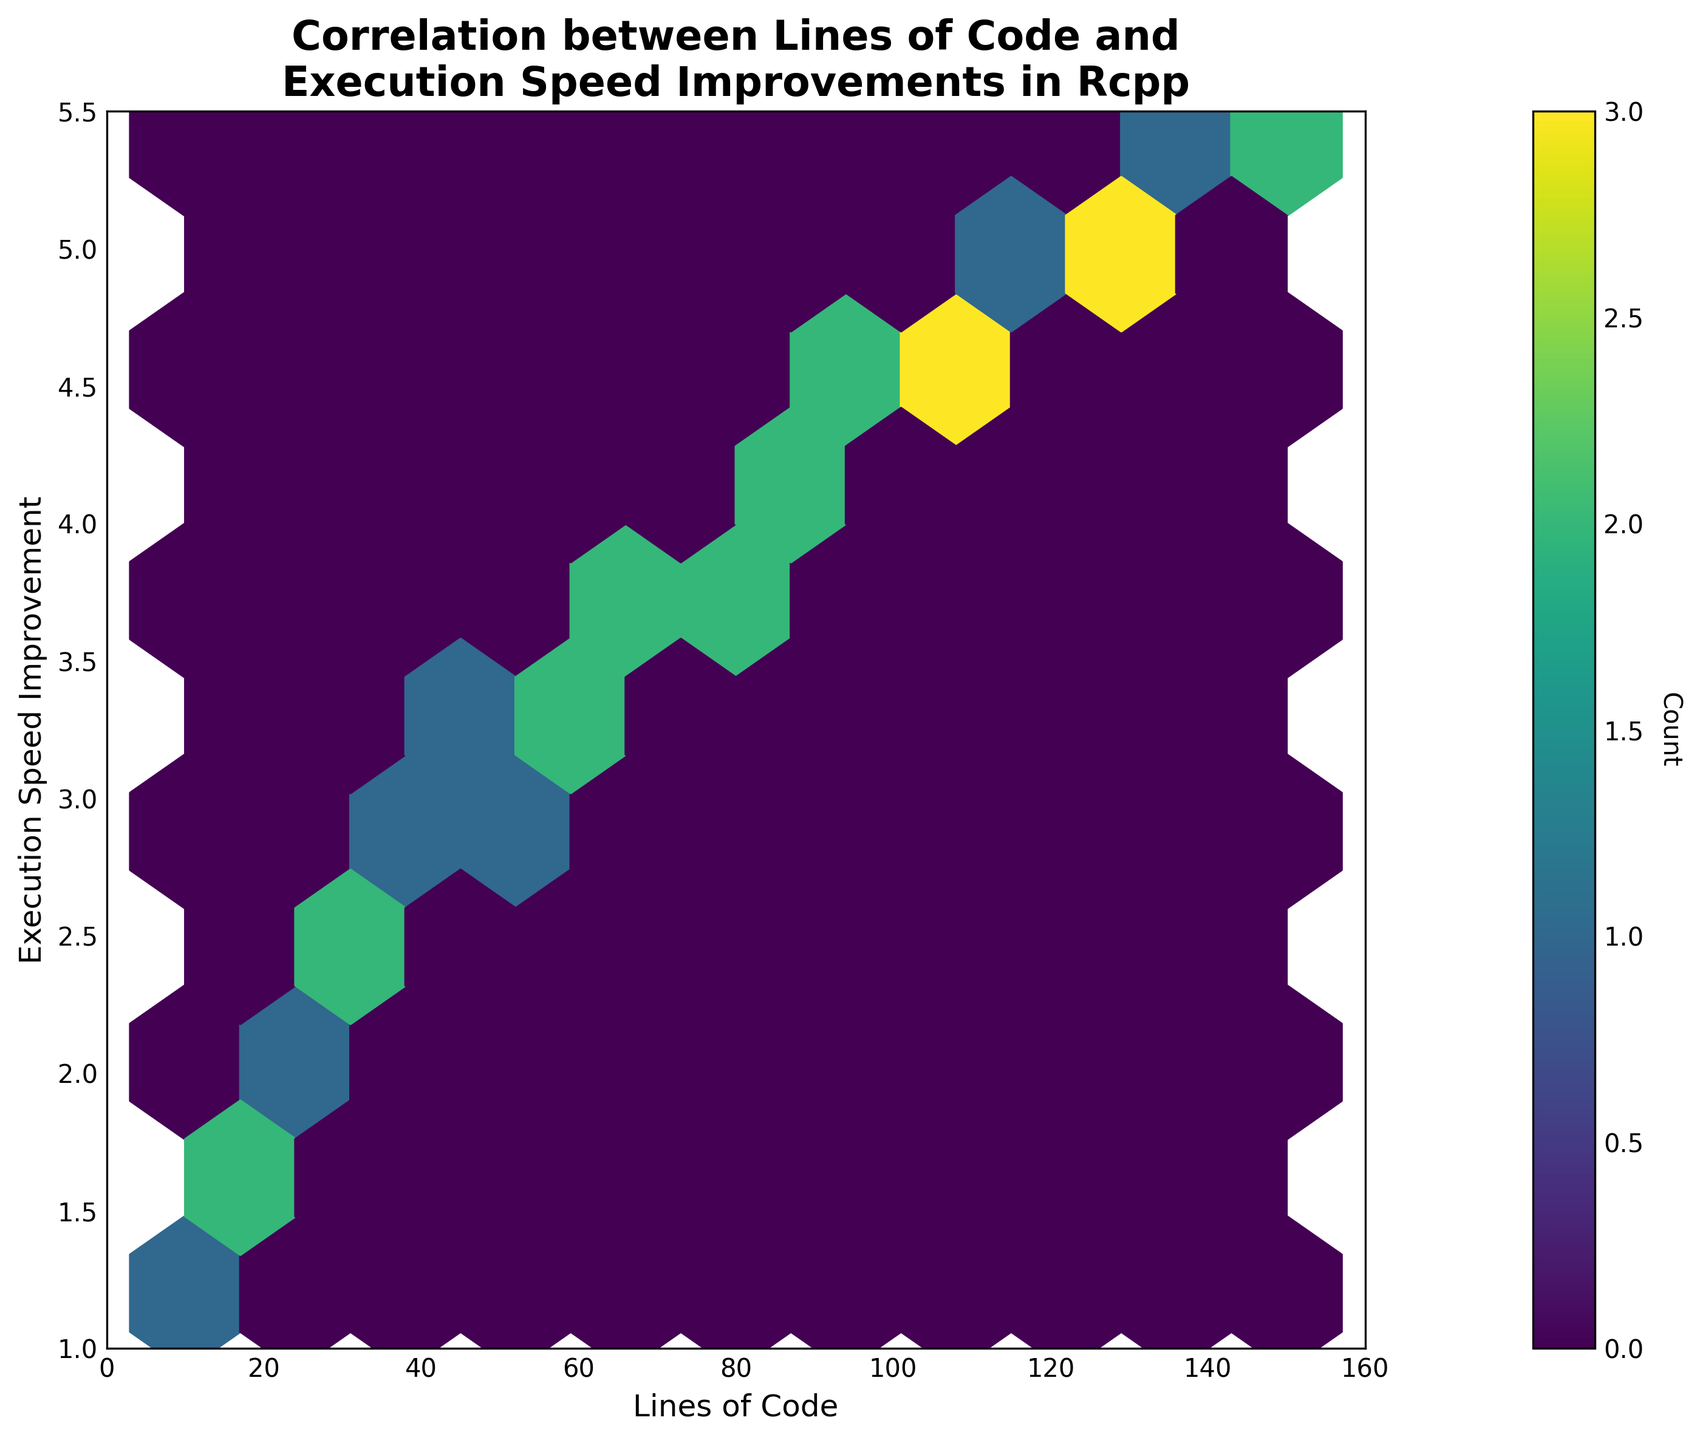What's the title of the figure? The title is located at the top of the figure and reads: "Correlation between Lines of Code and Execution Speed Improvements in Rcpp."
Answer: Correlation between Lines of Code and Execution Speed Improvements in Rcpp What's the x-axis label in the figure? The x-axis label is situated below the horizontal axis and it reads: "Lines of Code."
Answer: Lines of Code What's the y-axis label of the figure? The y-axis label, found beside the vertical axis, reads: "Execution Speed Improvement."
Answer: Execution Speed Improvement How does execution speed improvement vary with an increase in lines of code? By observing the hexbin plot, it is clear that the execution speed improvement generally increases as the lines of code increase. This pattern indicates a positive correlation between the two variables.
Answer: Increases Are there more data points in the range of 25-75 lines of code or in the range of 75-125 lines of code? The hexbin plot indicates the density of data points through color intensity. By comparing the color intensity (indicated by the color bar), the area from 25-75 lines of code shows a higher density of colored bins compared to 75-125 lines of code.
Answer: 25-75 lines of code Does the plot show any outliers in terms of execution speed improvement? By looking at the spread of data points, there are no significant isolated bins far from the main distribution trend. Hence, the plot does not display noticeable outliers in terms of execution speed improvement.
Answer: No In which range of lines of code do we see the highest execution speed improvement values? Observing the y-axis values on the hexbin plot, the highest execution speed improvement values appear to occur in the range of 130 to 150 lines of code.
Answer: 130-150 lines of code At approximately how many lines of code do we see an execution speed improvement of 2.5? By locating 2.5 on the y-axis and tracing it horizontally, we find that it aligns with approximately 35-40 lines of code on the x-axis.
Answer: 35-40 lines of code How does the color bar help in interpreting the hexbin plot? The color bar represents the count of data points within each hexbin, aiding in visualizing the density of occurrences for various ranges of lines of code and execution speed improvements. More saturated colors correspond to higher counts.
Answer: It indicates the count of data points in each bin 